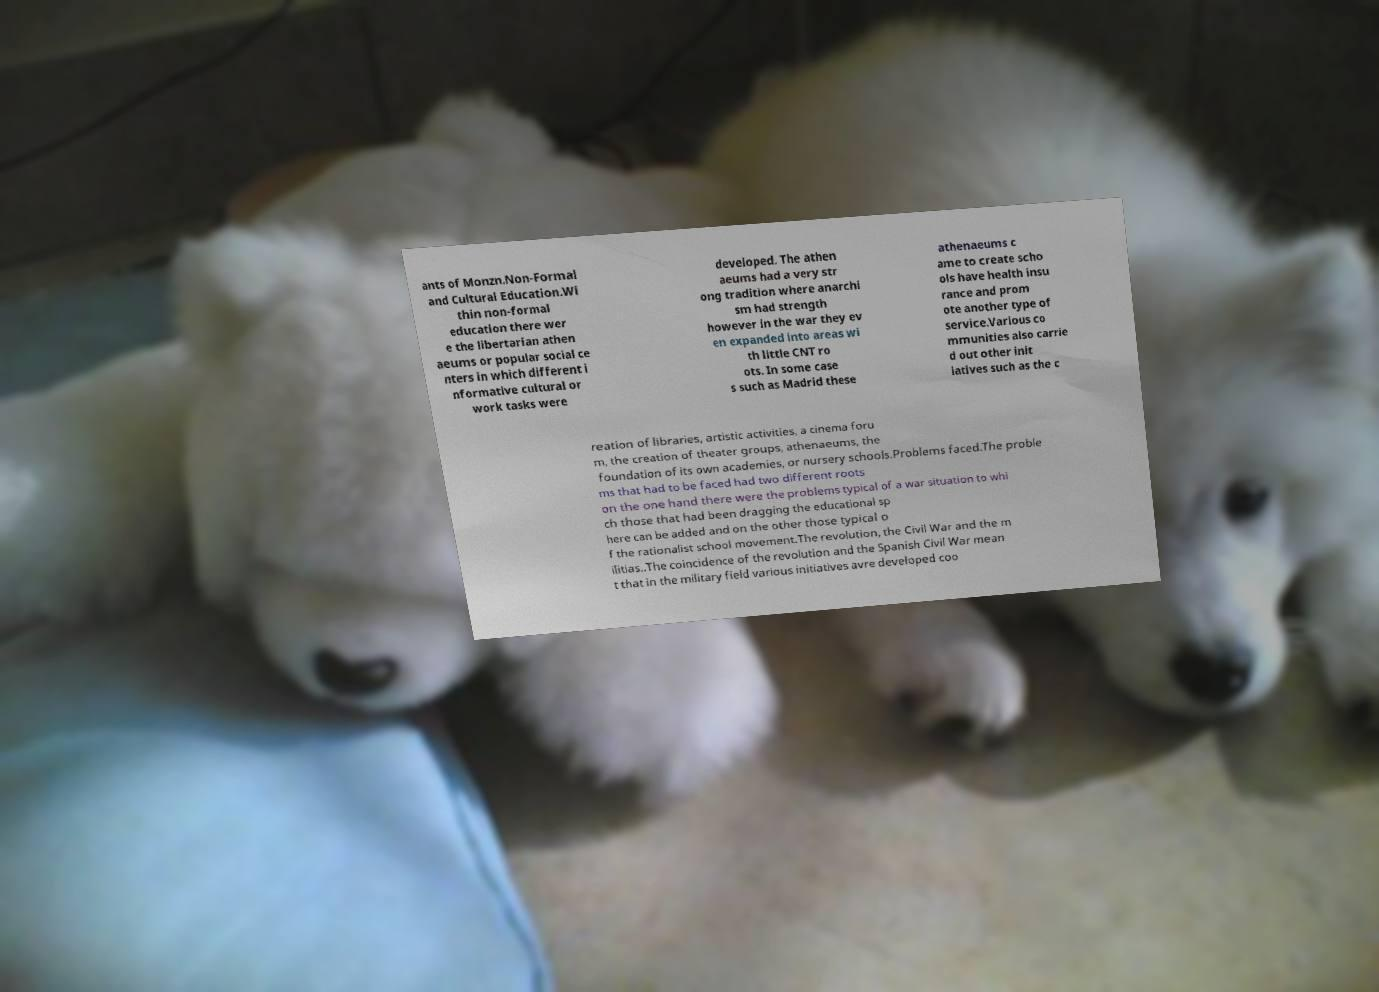Please identify and transcribe the text found in this image. ants of Monzn.Non-Formal and Cultural Education.Wi thin non-formal education there wer e the libertarian athen aeums or popular social ce nters in which different i nformative cultural or work tasks were developed. The athen aeums had a very str ong tradition where anarchi sm had strength however in the war they ev en expanded into areas wi th little CNT ro ots. In some case s such as Madrid these athenaeums c ame to create scho ols have health insu rance and prom ote another type of service.Various co mmunities also carrie d out other init iatives such as the c reation of libraries, artistic activities, a cinema foru m, the creation of theater groups, athenaeums, the foundation of its own academies, or nursery schools.Problems faced.The proble ms that had to be faced had two different roots on the one hand there were the problems typical of a war situation to whi ch those that had been dragging the educational sp here can be added and on the other those typical o f the rationalist school movement.The revolution, the Civil War and the m ilitias..The coincidence of the revolution and the Spanish Civil War mean t that in the military field various initiatives avre developed coo 